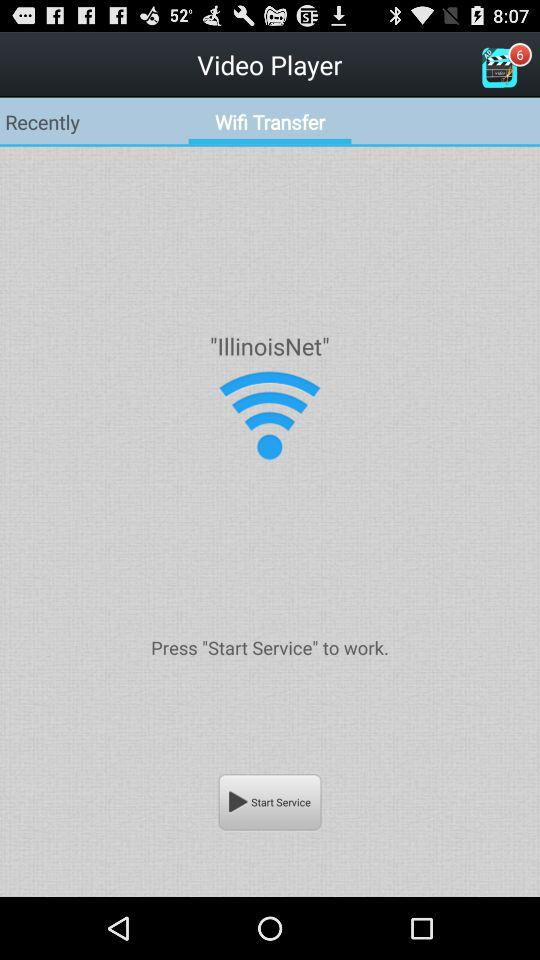What is listed in "Recently"?
When the provided information is insufficient, respond with <no answer>. <no answer> 